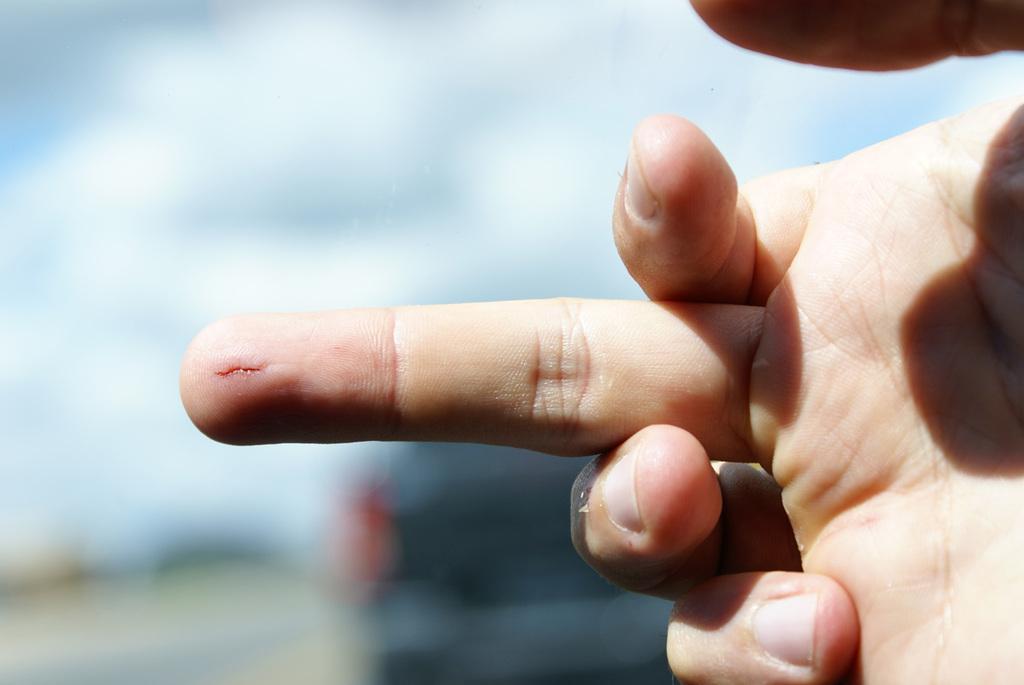Can you describe this image briefly? Here we can see a person hand and there is a cut mark on the finger. In the background the image is blur but we can see a vehicle. 